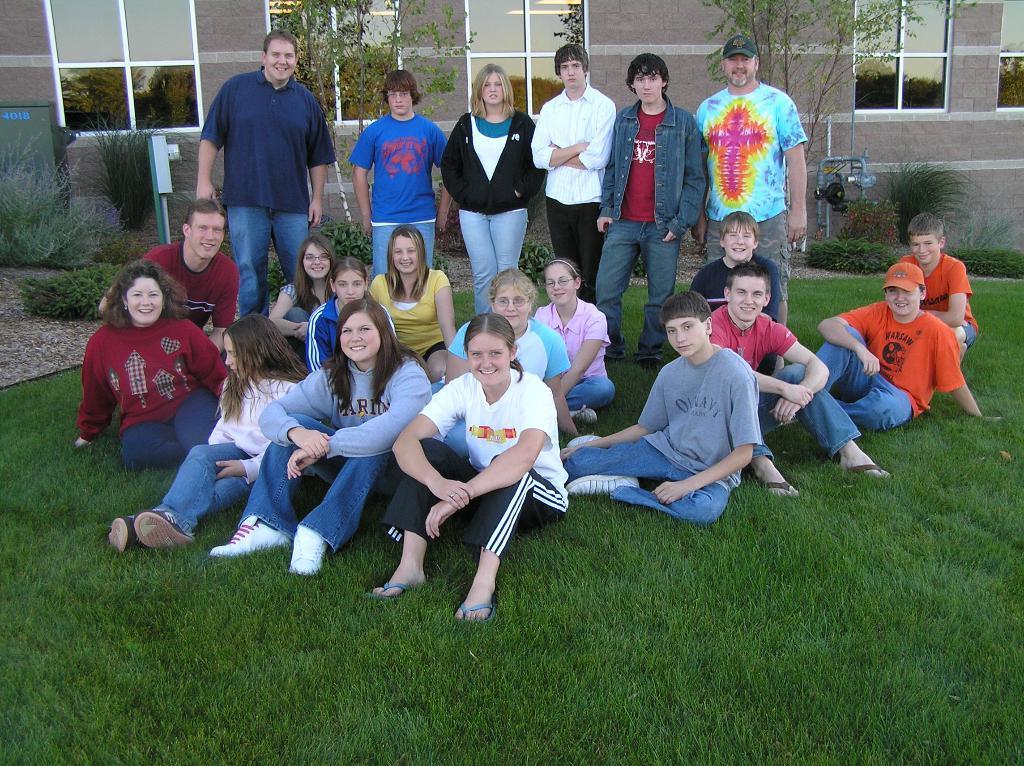Describe this image in one or two sentences. In the image there are boys and girls standing on the grassland and behind few people standing in front of building with trees in front of it. 